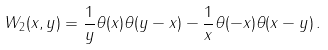<formula> <loc_0><loc_0><loc_500><loc_500>W _ { 2 } ( x , y ) = \frac { 1 } { y } \theta ( x ) \theta ( y - x ) - \frac { 1 } { x } \theta ( - x ) \theta ( x - y ) \, .</formula> 